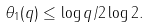Convert formula to latex. <formula><loc_0><loc_0><loc_500><loc_500>\theta _ { 1 } ( q ) \leq { \log q } / { 2 \log 2 } .</formula> 